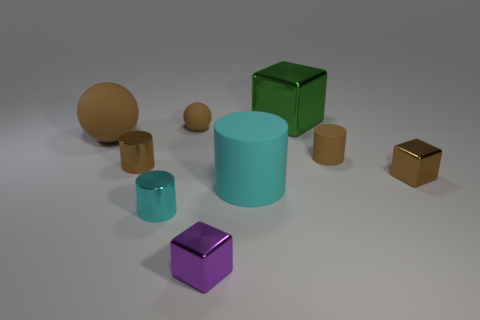What material is the other sphere that is the same color as the large sphere?
Offer a very short reply. Rubber. There is a purple thing that is made of the same material as the big cube; what shape is it?
Your answer should be very brief. Cube. How many small objects are behind the purple metal thing and on the left side of the big green metallic object?
Make the answer very short. 3. Are there any green things to the right of the large brown object?
Give a very brief answer. Yes. Is the shape of the big matte object that is on the left side of the purple object the same as the small brown rubber thing that is behind the small rubber cylinder?
Your response must be concise. Yes. How many things are brown matte cylinders or objects that are to the left of the green shiny thing?
Provide a short and direct response. 7. How many other things are the same shape as the green object?
Your answer should be very brief. 2. Does the cube that is behind the tiny brown block have the same material as the big cyan cylinder?
Your response must be concise. No. How many objects are either cylinders or small yellow rubber blocks?
Offer a terse response. 4. There is a green object that is the same shape as the purple metallic thing; what size is it?
Your answer should be very brief. Large. 